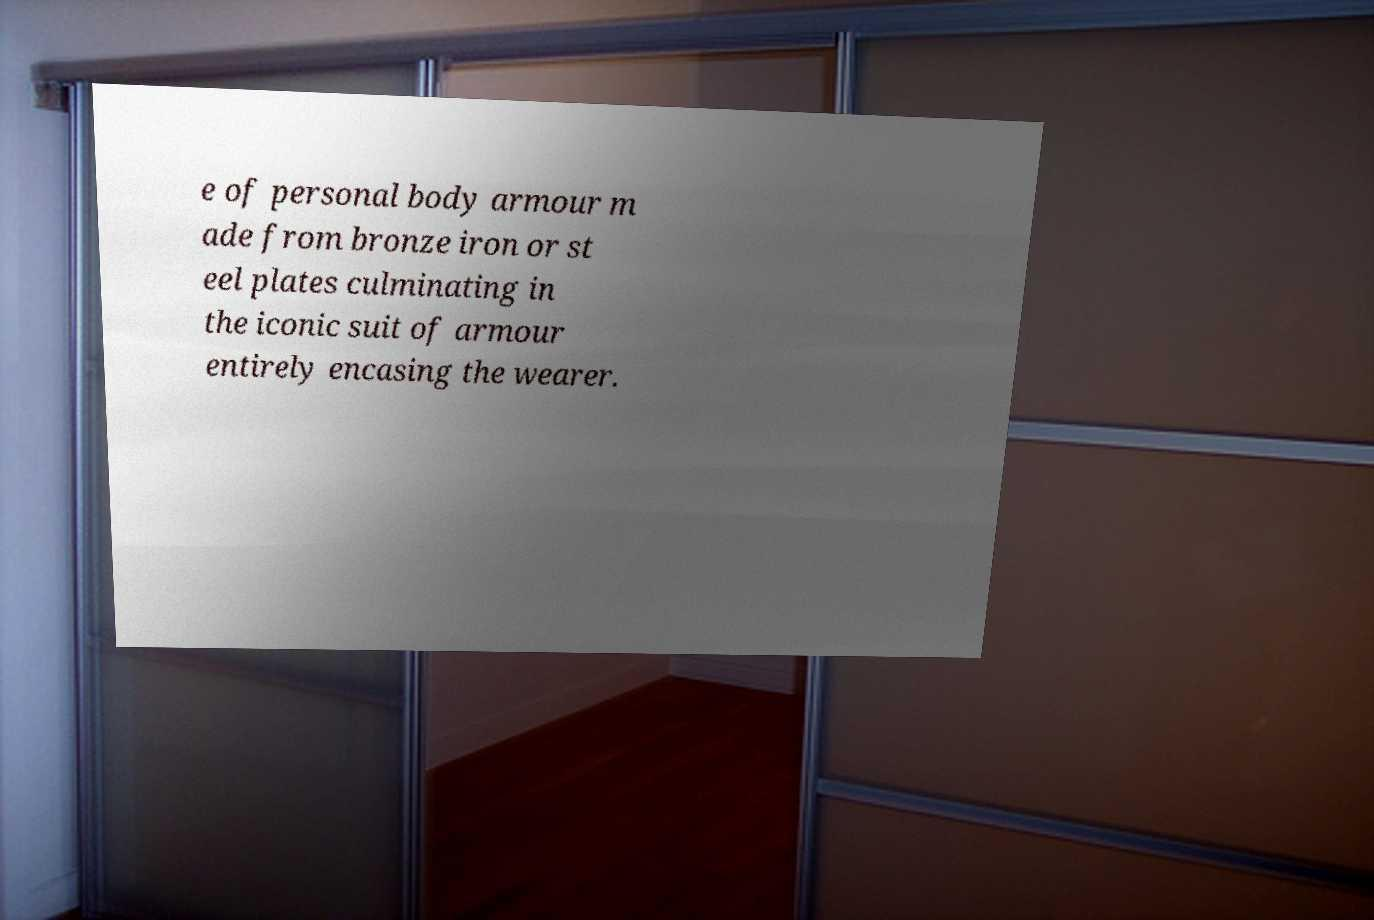Please identify and transcribe the text found in this image. e of personal body armour m ade from bronze iron or st eel plates culminating in the iconic suit of armour entirely encasing the wearer. 